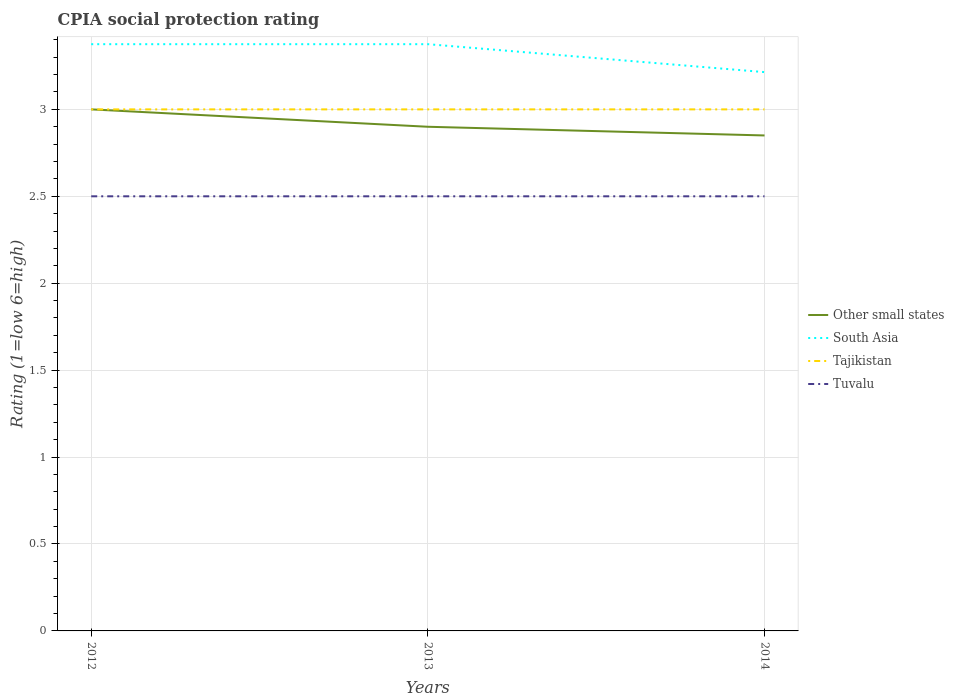Does the line corresponding to Tuvalu intersect with the line corresponding to South Asia?
Offer a terse response. No. Is the number of lines equal to the number of legend labels?
Offer a very short reply. Yes. Across all years, what is the maximum CPIA rating in South Asia?
Your response must be concise. 3.21. What is the total CPIA rating in Tajikistan in the graph?
Your response must be concise. 0. Is the CPIA rating in Tuvalu strictly greater than the CPIA rating in Other small states over the years?
Provide a succinct answer. Yes. How many lines are there?
Provide a succinct answer. 4. What is the difference between two consecutive major ticks on the Y-axis?
Keep it short and to the point. 0.5. Does the graph contain any zero values?
Give a very brief answer. No. Does the graph contain grids?
Provide a short and direct response. Yes. What is the title of the graph?
Provide a succinct answer. CPIA social protection rating. What is the label or title of the X-axis?
Your response must be concise. Years. What is the Rating (1=low 6=high) of South Asia in 2012?
Make the answer very short. 3.38. What is the Rating (1=low 6=high) of Tajikistan in 2012?
Offer a terse response. 3. What is the Rating (1=low 6=high) of Tuvalu in 2012?
Your response must be concise. 2.5. What is the Rating (1=low 6=high) in Other small states in 2013?
Give a very brief answer. 2.9. What is the Rating (1=low 6=high) in South Asia in 2013?
Provide a succinct answer. 3.38. What is the Rating (1=low 6=high) of Tuvalu in 2013?
Give a very brief answer. 2.5. What is the Rating (1=low 6=high) of Other small states in 2014?
Offer a terse response. 2.85. What is the Rating (1=low 6=high) of South Asia in 2014?
Your answer should be very brief. 3.21. Across all years, what is the maximum Rating (1=low 6=high) in South Asia?
Your answer should be very brief. 3.38. Across all years, what is the maximum Rating (1=low 6=high) in Tajikistan?
Provide a succinct answer. 3. Across all years, what is the minimum Rating (1=low 6=high) of Other small states?
Offer a terse response. 2.85. Across all years, what is the minimum Rating (1=low 6=high) of South Asia?
Make the answer very short. 3.21. Across all years, what is the minimum Rating (1=low 6=high) in Tajikistan?
Your answer should be compact. 3. Across all years, what is the minimum Rating (1=low 6=high) of Tuvalu?
Give a very brief answer. 2.5. What is the total Rating (1=low 6=high) in Other small states in the graph?
Make the answer very short. 8.75. What is the total Rating (1=low 6=high) of South Asia in the graph?
Give a very brief answer. 9.96. What is the total Rating (1=low 6=high) of Tuvalu in the graph?
Your answer should be very brief. 7.5. What is the difference between the Rating (1=low 6=high) of Other small states in 2012 and that in 2013?
Provide a succinct answer. 0.1. What is the difference between the Rating (1=low 6=high) in South Asia in 2012 and that in 2014?
Offer a very short reply. 0.16. What is the difference between the Rating (1=low 6=high) of Tuvalu in 2012 and that in 2014?
Give a very brief answer. 0. What is the difference between the Rating (1=low 6=high) in South Asia in 2013 and that in 2014?
Make the answer very short. 0.16. What is the difference between the Rating (1=low 6=high) in Tuvalu in 2013 and that in 2014?
Provide a succinct answer. 0. What is the difference between the Rating (1=low 6=high) in Other small states in 2012 and the Rating (1=low 6=high) in South Asia in 2013?
Provide a succinct answer. -0.38. What is the difference between the Rating (1=low 6=high) of Other small states in 2012 and the Rating (1=low 6=high) of Tajikistan in 2013?
Make the answer very short. 0. What is the difference between the Rating (1=low 6=high) of South Asia in 2012 and the Rating (1=low 6=high) of Tuvalu in 2013?
Offer a very short reply. 0.88. What is the difference between the Rating (1=low 6=high) in Other small states in 2012 and the Rating (1=low 6=high) in South Asia in 2014?
Offer a terse response. -0.21. What is the difference between the Rating (1=low 6=high) in Other small states in 2012 and the Rating (1=low 6=high) in Tuvalu in 2014?
Your response must be concise. 0.5. What is the difference between the Rating (1=low 6=high) in South Asia in 2012 and the Rating (1=low 6=high) in Tajikistan in 2014?
Provide a short and direct response. 0.38. What is the difference between the Rating (1=low 6=high) in South Asia in 2012 and the Rating (1=low 6=high) in Tuvalu in 2014?
Keep it short and to the point. 0.88. What is the difference between the Rating (1=low 6=high) in Tajikistan in 2012 and the Rating (1=low 6=high) in Tuvalu in 2014?
Keep it short and to the point. 0.5. What is the difference between the Rating (1=low 6=high) of Other small states in 2013 and the Rating (1=low 6=high) of South Asia in 2014?
Offer a terse response. -0.31. What is the average Rating (1=low 6=high) in Other small states per year?
Ensure brevity in your answer.  2.92. What is the average Rating (1=low 6=high) in South Asia per year?
Give a very brief answer. 3.32. What is the average Rating (1=low 6=high) of Tajikistan per year?
Make the answer very short. 3. What is the average Rating (1=low 6=high) in Tuvalu per year?
Offer a very short reply. 2.5. In the year 2012, what is the difference between the Rating (1=low 6=high) of Other small states and Rating (1=low 6=high) of South Asia?
Ensure brevity in your answer.  -0.38. In the year 2012, what is the difference between the Rating (1=low 6=high) of Other small states and Rating (1=low 6=high) of Tuvalu?
Give a very brief answer. 0.5. In the year 2012, what is the difference between the Rating (1=low 6=high) of South Asia and Rating (1=low 6=high) of Tuvalu?
Provide a succinct answer. 0.88. In the year 2013, what is the difference between the Rating (1=low 6=high) in Other small states and Rating (1=low 6=high) in South Asia?
Provide a short and direct response. -0.47. In the year 2013, what is the difference between the Rating (1=low 6=high) in Other small states and Rating (1=low 6=high) in Tuvalu?
Offer a very short reply. 0.4. In the year 2013, what is the difference between the Rating (1=low 6=high) of South Asia and Rating (1=low 6=high) of Tajikistan?
Make the answer very short. 0.38. In the year 2013, what is the difference between the Rating (1=low 6=high) of Tajikistan and Rating (1=low 6=high) of Tuvalu?
Give a very brief answer. 0.5. In the year 2014, what is the difference between the Rating (1=low 6=high) in Other small states and Rating (1=low 6=high) in South Asia?
Provide a succinct answer. -0.36. In the year 2014, what is the difference between the Rating (1=low 6=high) of Other small states and Rating (1=low 6=high) of Tajikistan?
Make the answer very short. -0.15. In the year 2014, what is the difference between the Rating (1=low 6=high) in Other small states and Rating (1=low 6=high) in Tuvalu?
Offer a terse response. 0.35. In the year 2014, what is the difference between the Rating (1=low 6=high) in South Asia and Rating (1=low 6=high) in Tajikistan?
Provide a short and direct response. 0.21. What is the ratio of the Rating (1=low 6=high) of Other small states in 2012 to that in 2013?
Your response must be concise. 1.03. What is the ratio of the Rating (1=low 6=high) in South Asia in 2012 to that in 2013?
Give a very brief answer. 1. What is the ratio of the Rating (1=low 6=high) in Tajikistan in 2012 to that in 2013?
Keep it short and to the point. 1. What is the ratio of the Rating (1=low 6=high) of Tuvalu in 2012 to that in 2013?
Make the answer very short. 1. What is the ratio of the Rating (1=low 6=high) in Other small states in 2012 to that in 2014?
Offer a very short reply. 1.05. What is the ratio of the Rating (1=low 6=high) of South Asia in 2012 to that in 2014?
Offer a very short reply. 1.05. What is the ratio of the Rating (1=low 6=high) of Other small states in 2013 to that in 2014?
Provide a short and direct response. 1.02. What is the ratio of the Rating (1=low 6=high) in South Asia in 2013 to that in 2014?
Make the answer very short. 1.05. What is the difference between the highest and the second highest Rating (1=low 6=high) of Tajikistan?
Offer a very short reply. 0. What is the difference between the highest and the lowest Rating (1=low 6=high) of South Asia?
Offer a terse response. 0.16. What is the difference between the highest and the lowest Rating (1=low 6=high) of Tajikistan?
Your answer should be compact. 0. What is the difference between the highest and the lowest Rating (1=low 6=high) in Tuvalu?
Keep it short and to the point. 0. 